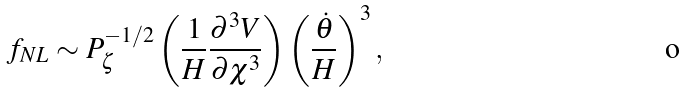<formula> <loc_0><loc_0><loc_500><loc_500>f _ { N L } \sim P _ { \zeta } ^ { - 1 / 2 } \left ( \frac { 1 } { H } \frac { \partial ^ { 3 } V } { \partial \chi ^ { 3 } } \right ) \left ( \frac { \dot { \theta } } { H } \right ) ^ { 3 } ,</formula> 